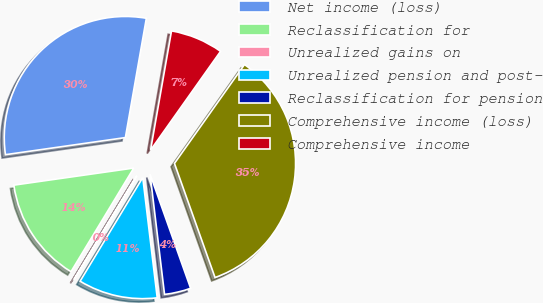<chart> <loc_0><loc_0><loc_500><loc_500><pie_chart><fcel>Net income (loss)<fcel>Reclassification for<fcel>Unrealized gains on<fcel>Unrealized pension and post-<fcel>Reclassification for pension<fcel>Comprehensive income (loss)<fcel>Comprehensive income<nl><fcel>30.02%<fcel>14.08%<fcel>0.01%<fcel>10.56%<fcel>3.53%<fcel>34.75%<fcel>7.04%<nl></chart> 